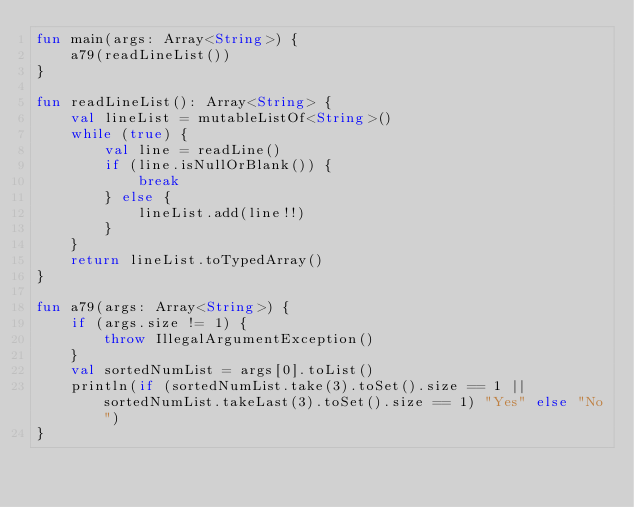Convert code to text. <code><loc_0><loc_0><loc_500><loc_500><_Kotlin_>fun main(args: Array<String>) {
    a79(readLineList())
}

fun readLineList(): Array<String> {
    val lineList = mutableListOf<String>()
    while (true) {
        val line = readLine()
        if (line.isNullOrBlank()) {
            break
        } else {
            lineList.add(line!!)
        }
    }
    return lineList.toTypedArray()
}

fun a79(args: Array<String>) {
    if (args.size != 1) {
        throw IllegalArgumentException()
    }
    val sortedNumList = args[0].toList()
    println(if (sortedNumList.take(3).toSet().size == 1 || sortedNumList.takeLast(3).toSet().size == 1) "Yes" else "No")
}</code> 